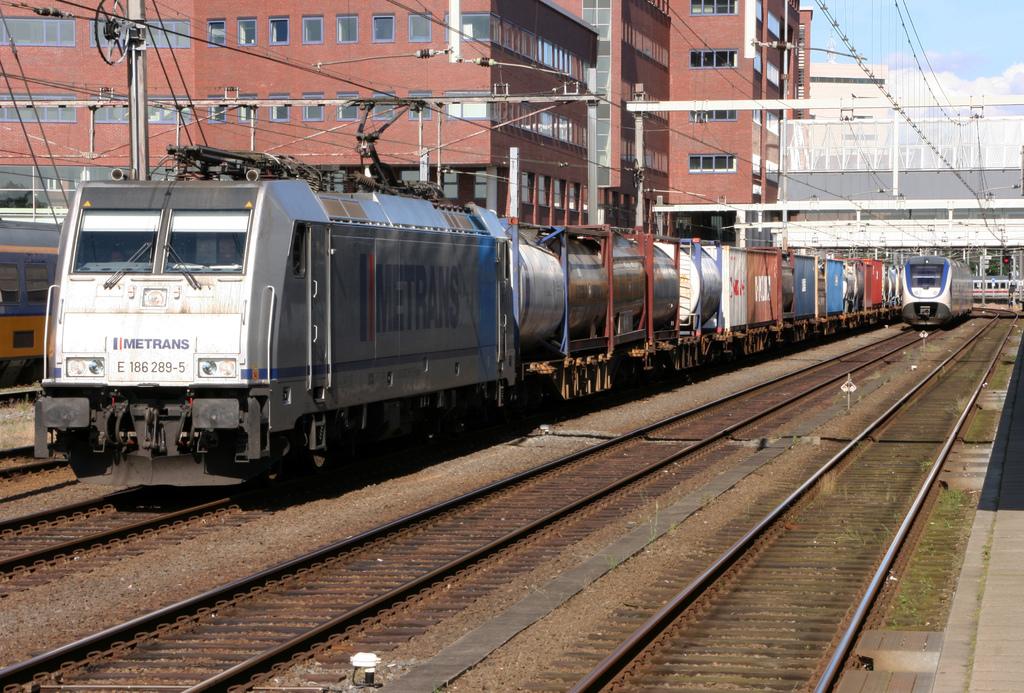What is the last digit written on the front of the train?
Make the answer very short. 5. What is the name of the company?
Your response must be concise. Metrans. 